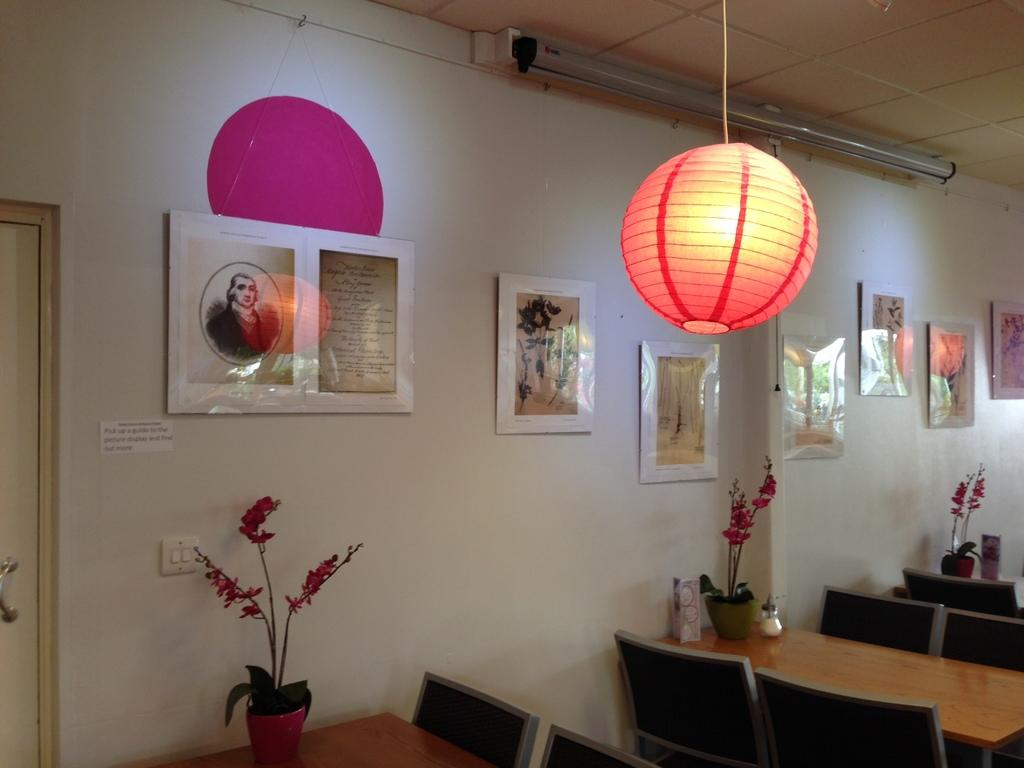What type of furniture is present in the image? There are tables and chairs in the image. Where are the tables and chairs located? The tables and chairs are located at the bottom right of the image. What is placed on the tables? There are plants on each table. What can be seen in the image that provides illumination? There are lights visible in the image. What type of decoration is present on the wall? There are portraits on the wall. What type of stamp can be seen on the chairs in the image? There is no stamp present on the chairs in the image. What is the angle of the tables in the image? The angle of the tables cannot be determined from the image, as they appear to be stationary and upright. 